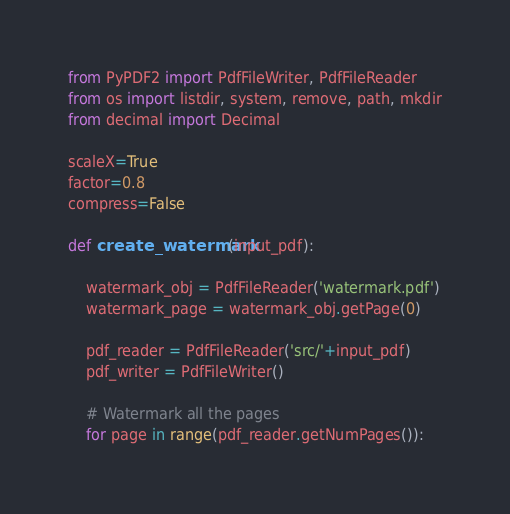Convert code to text. <code><loc_0><loc_0><loc_500><loc_500><_Python_>from PyPDF2 import PdfFileWriter, PdfFileReader
from os import listdir, system, remove, path, mkdir
from decimal import Decimal

scaleX=True
factor=0.8
compress=False

def create_watermark(input_pdf):
    
    watermark_obj = PdfFileReader('watermark.pdf')
    watermark_page = watermark_obj.getPage(0)

    pdf_reader = PdfFileReader('src/'+input_pdf)
    pdf_writer = PdfFileWriter()

    # Watermark all the pages
    for page in range(pdf_reader.getNumPages()):</code> 